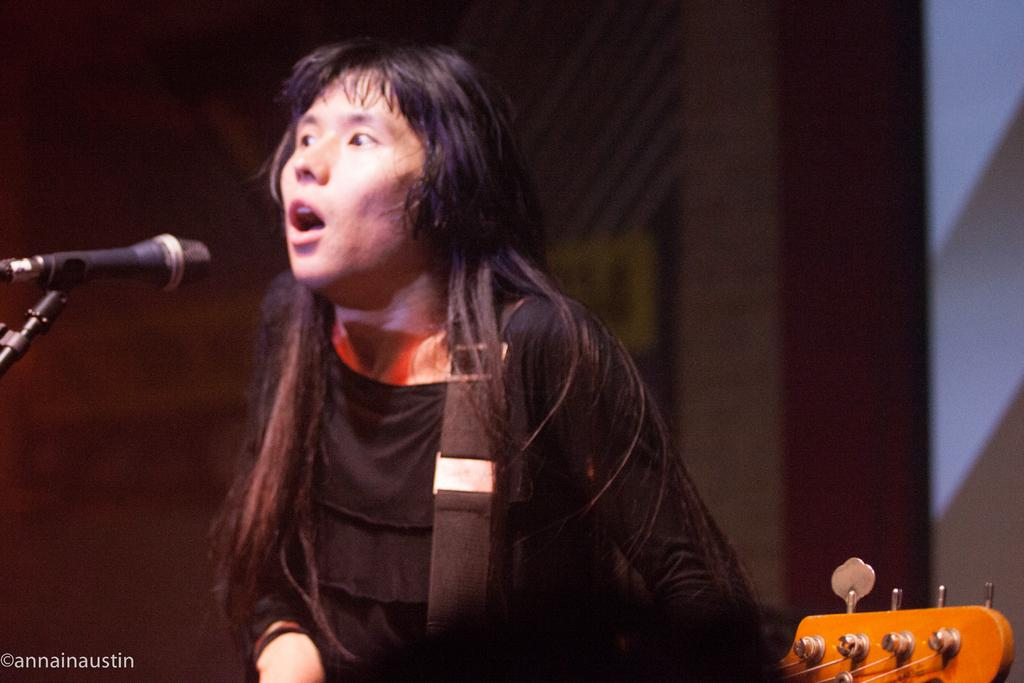What is the main subject of the image? There is a woman standing in the image. What object is present that is typically used for amplifying sound? There is a microphone in the image. Is there any support for the microphone in the image? Yes, there is a stand for the microphone in the image. What other musical element can be seen in the image? There is a musical instrument in the image. What type of umbrella is being used to protect the musical instrument from the rain in the image? There is no umbrella present in the image, and the musical instrument is not being protected from the rain. 